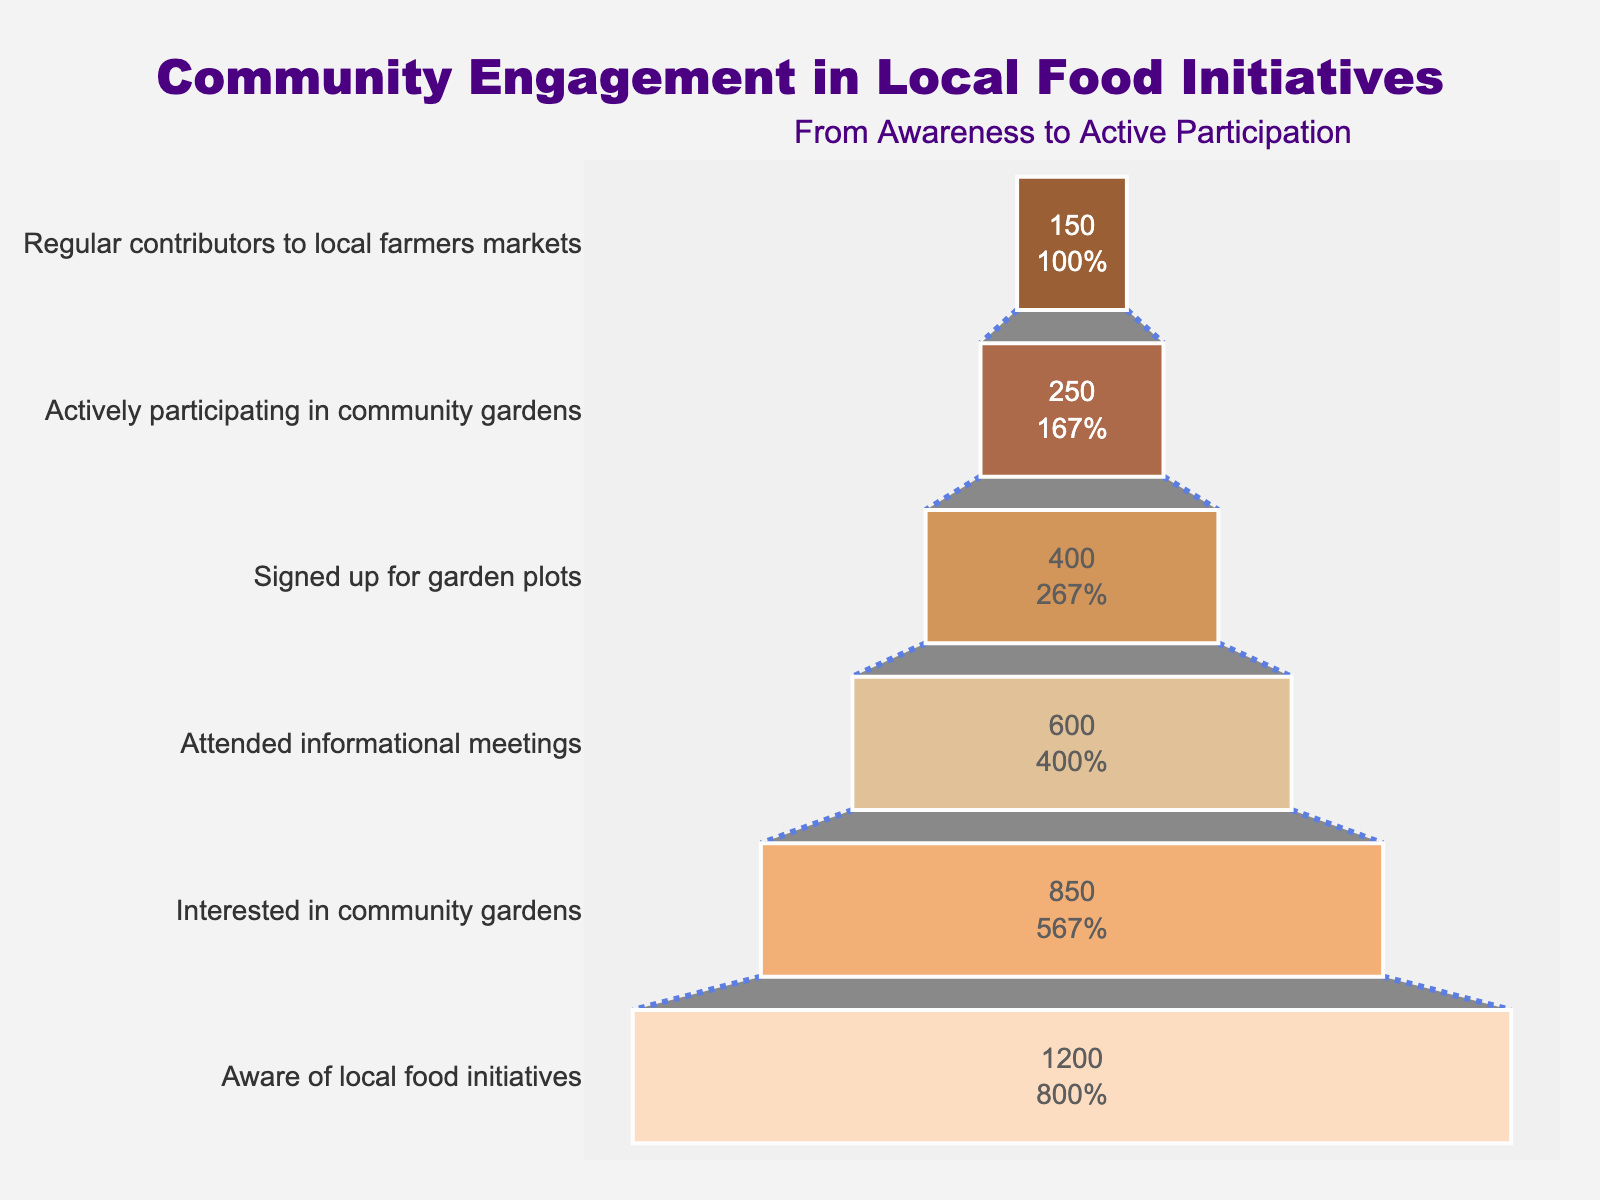What's the title of the funnel chart? The title of the funnel chart is located at the top and describes the chart's main subject.
Answer: Community Engagement in Local Food Initiatives How many residents are actively participating in community gardens? The active participation stage in community gardens is labeled in the funnel chart, showing the number of residents involved.
Answer: 250 Which stage has the highest number of residents? By analyzing the bars in the funnel chart, the stage with the widest bar at the bottom indicates the highest number of residents.
Answer: Aware of local food initiatives What percentage of residents who are aware of local food initiatives are actively participating in community gardens? To find the percentage, divide the number of residents actively participating in community gardens by those aware and multiply by 100: (250/1200) * 100
Answer: 20.83% Compare the interest in community gardens to active participation. How many fewer residents are there in active participation compared to those interested? Subtract the number of residents actively participating from those interested in community gardens: 850 - 250
Answer: 600 How has the number of residents changed from attending informational meetings to signing up for garden plots? Calculate the difference between the residents attending informational meetings and those who signed up for garden plots: 600 - 400
Answer: 200 What is the primary color used for the 'Aware of local food initiatives' stage in the funnel chart? Each stage in the funnel chart has a distinct color; observe the color for the specific stage.
Answer: Peach (light orange) What percentage of residents who signed up for garden plots are regular contributors to local farmers markets? To determine the percentage, divide the number of regular contributors by those who signed up for garden plots and multiply by 100: (150/400) * 100
Answer: 37.5% Which two stages have exactly 200 resident difference? Compare the listed numbers of residents between different stages to identify pairs with a 200 resident difference.
Answer: Attended informational meetings and signed up for garden plots What percentage of the initial group aware of local food initiatives attended informational meetings? Divide the number of those who attended informational meetings by the initial group aware and multiply by 100: (600/1200) * 100
Answer: 50% 